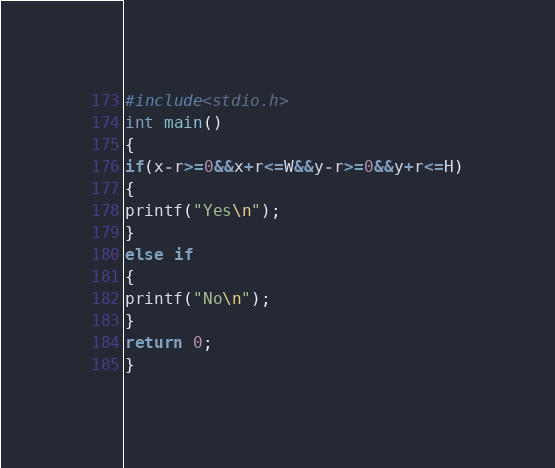Convert code to text. <code><loc_0><loc_0><loc_500><loc_500><_C_>#include<stdio.h>
int main()
{
if(x-r>=0&&x+r<=W&&y-r>=0&&y+r<=H)
{
printf("Yes\n");
}
else if
{
printf("No\n");
}
return 0;
}</code> 